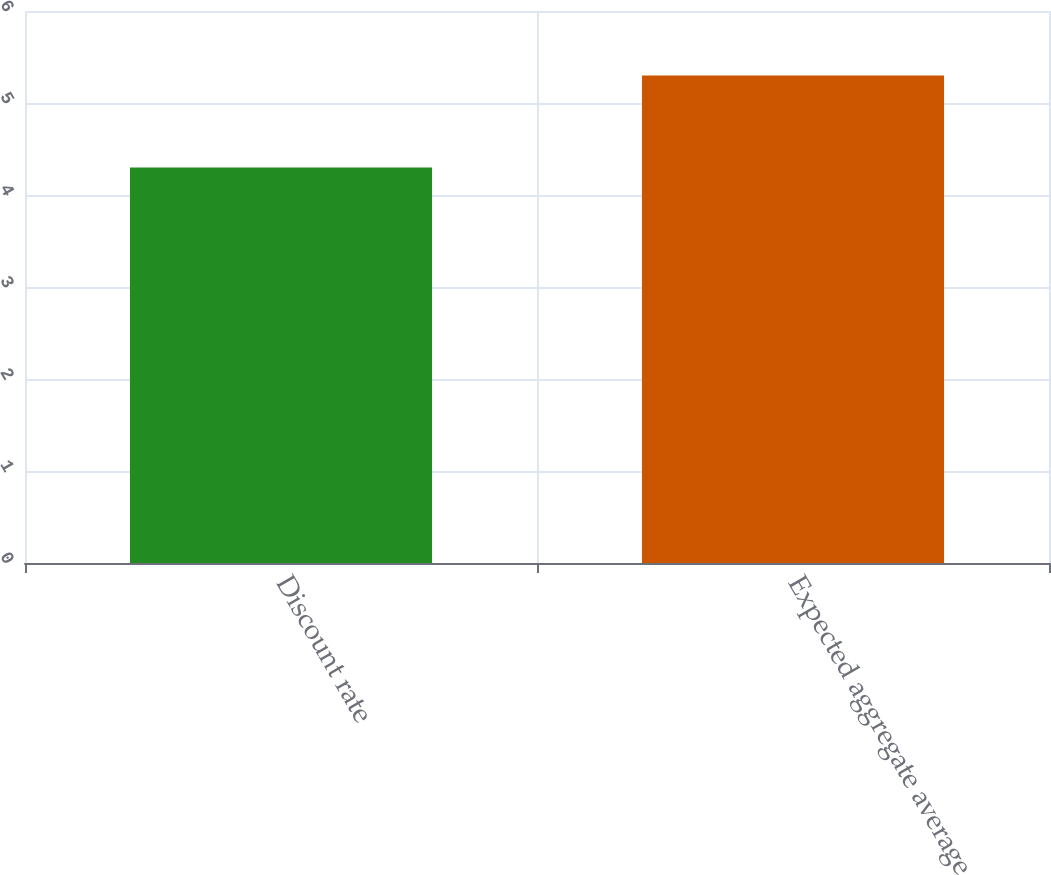<chart> <loc_0><loc_0><loc_500><loc_500><bar_chart><fcel>Discount rate<fcel>Expected aggregate average<nl><fcel>4.3<fcel>5.3<nl></chart> 